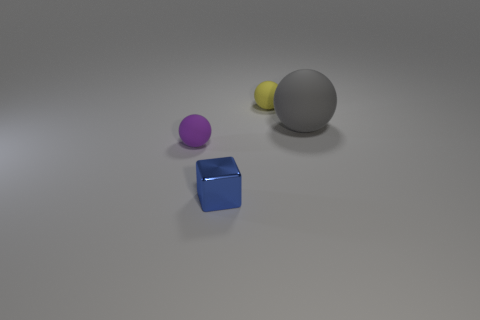There is a small matte ball that is on the left side of the tiny yellow matte thing; what number of things are left of it? There are no objects to the left of the small yellow matte thing. It is positioned at the far left relative to the perspective from which we're viewing the image, with other objects placed to its right. 